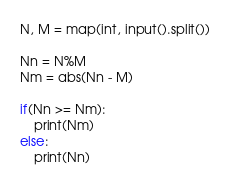Convert code to text. <code><loc_0><loc_0><loc_500><loc_500><_Python_>N, M = map(int, input().split())

Nn = N%M
Nm = abs(Nn - M)

if(Nn >= Nm):
    print(Nm)
else:
    print(Nn)</code> 